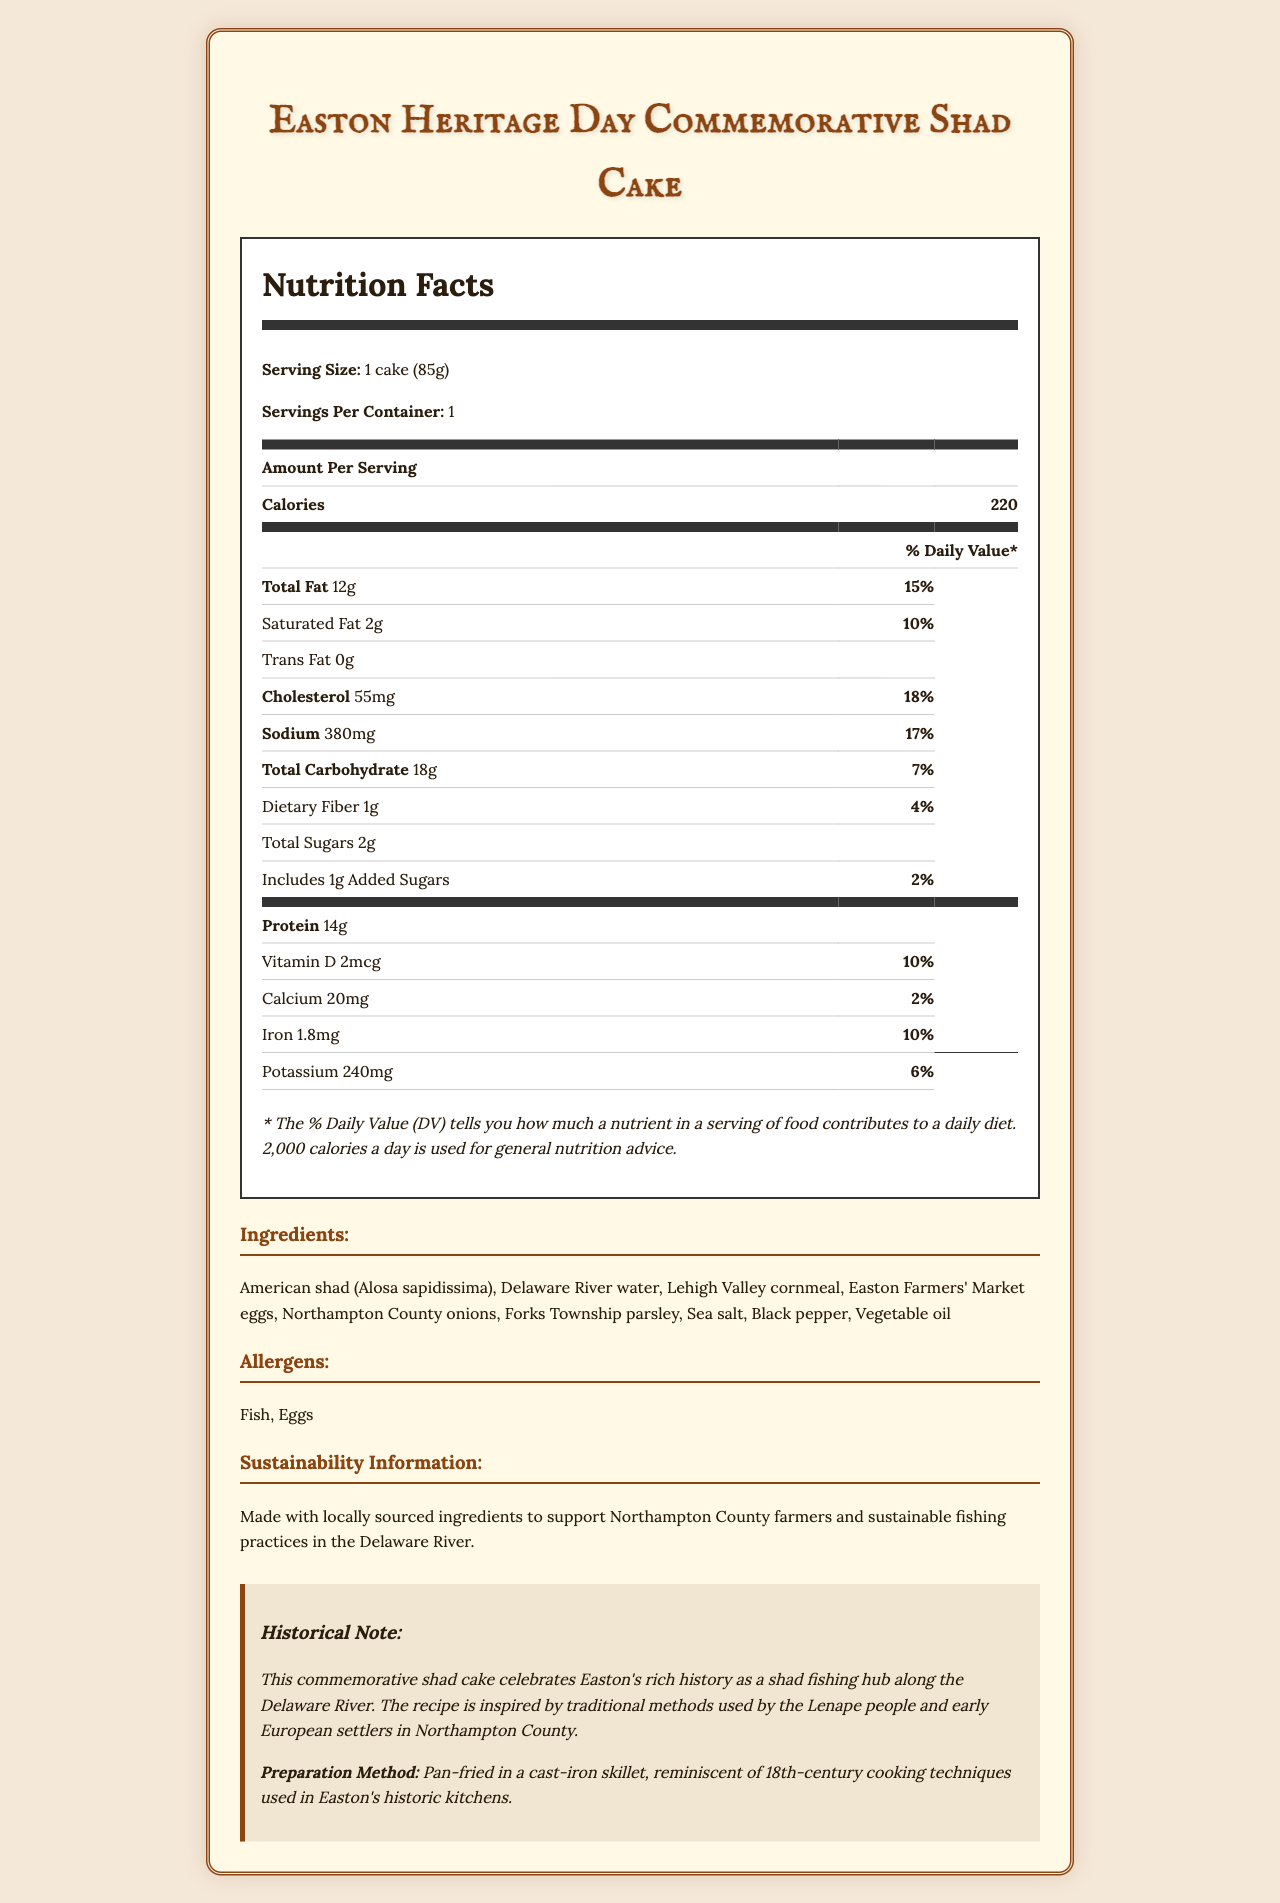what is the serving size of the Easton Heritage Day Commemorative Shad Cake? The serving size is clearly listed as "1 cake (85g)" in the Nutrition Facts section of the document.
Answer: 1 cake (85g) how many calories are in one serving of the shad cake? The document states that there are "220 calories" per serving.
Answer: 220 what are the main allergens mentioned in the document? The allergens are listed directly under the allergens section as "Fish, Eggs".
Answer: Fish, Eggs how much protein does one shad cake contain? The Nutrition Facts section lists the protein content as "14g".
Answer: 14g what percentage of the daily value of sodium does one shad cake provide? The document specifies that one shad cake provides 17% of the daily value of sodium.
Answer: 17% which ingredient is sourced from the Delaware River? The ingredients list includes "American shad (Alosa sapidissima)" and "Delaware River water," indicating they are sourced from the Delaware River.
Answer: American shad (Alosa sapidissima), Delaware River water what is the historical significance of the shad cake according to the document? The historical note section states that the shad cake celebrates Easton's history as a shad fishing hub and is inspired by traditional methods used by the Lenape people and early European settlers in Northampton County.
Answer: Celebrates Easton's history as a shad fishing hub, inspired by methods used by the Lenape people and early European settlers. how is the shad cake prepared? The document mentions that the shad cake is pan-fried in a cast-iron skillet, reminiscent of 18th-century cooking techniques.
Answer: Pan-fried in a cast-iron skillet. which of the following nutrients is not listed in the Nutrition Facts? A. Vitamin D B. Vitamin C C. Calcium D. Iron Vitamin D, Calcium, and Iron are listed, but Vitamin C is not mentioned in the Nutrition Facts.
Answer: B. Vitamin C what is the primary fat content of the shad cake, and how much of it is saturated fat? A. Total Fat: 12g, Saturated Fat: 10% B. Total Fat: 12g, Saturated Fat: 2g C. Total Fat: 15%, Saturated Fat: 10% D. Saturated Fat: 2g, Trans Fat: 0g The document lists Total Fat as 12g and Saturated Fat as 2g.
Answer: B. Total Fat: 12g, Saturated Fat: 2g does the document provide any details about the impact of the shad cake on cardiovascular health? The document does not discuss the impact of the shad cake on cardiovascular health.
Answer: No summarize the main idea of the document. The document is a comprehensive overview of the Easton Heritage Day Commemorative Shad Cake, including detailed nutritional information, a list of ingredients, and notes on historical and sustainability aspects.
Answer: The document provides the Nutrition Facts, ingredients, allergens, historical significance, and sustainability information for the Easton Heritage Day Commemorative Shad Cake. It highlights the locally sourced ingredients, the historical traditions it celebrates, and the nutritional content of the food item. what was the method for sourcing the nutritional data? The document does not provide information on how the nutritional data was sourced or calculated.
Answer: Cannot be determined 